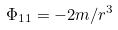Convert formula to latex. <formula><loc_0><loc_0><loc_500><loc_500>\Phi _ { 1 1 } = - 2 m / r ^ { 3 }</formula> 